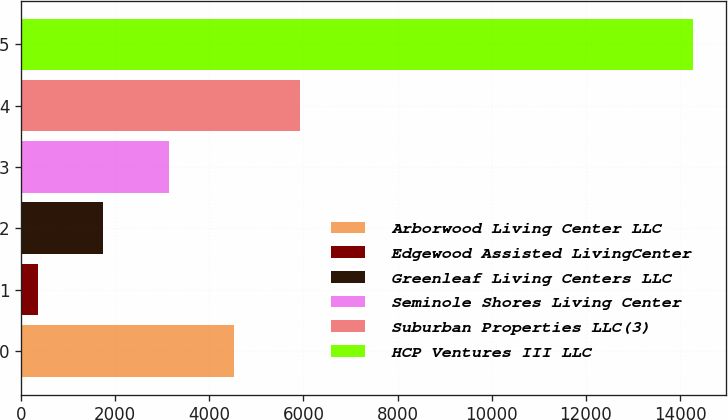Convert chart to OTSL. <chart><loc_0><loc_0><loc_500><loc_500><bar_chart><fcel>Arborwood Living Center LLC<fcel>Edgewood Assisted LivingCenter<fcel>Greenleaf Living Centers LLC<fcel>Seminole Shores Living Center<fcel>Suburban Properties LLC(3)<fcel>HCP Ventures III LLC<nl><fcel>4526.8<fcel>352<fcel>1743.6<fcel>3135.2<fcel>5918.4<fcel>14268<nl></chart> 